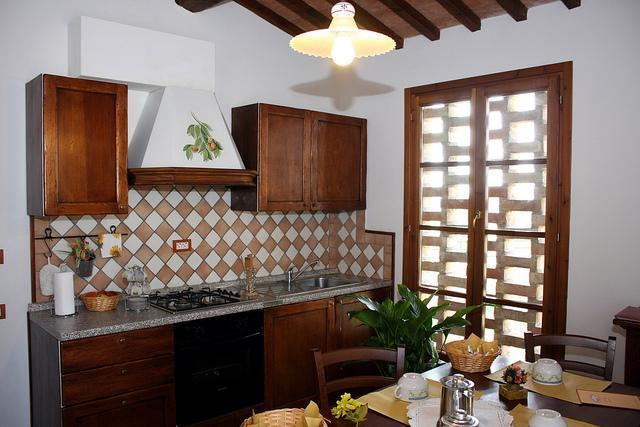How many lamps are in this room?
Give a very brief answer. 1. How many chairs are in the picture?
Give a very brief answer. 2. 